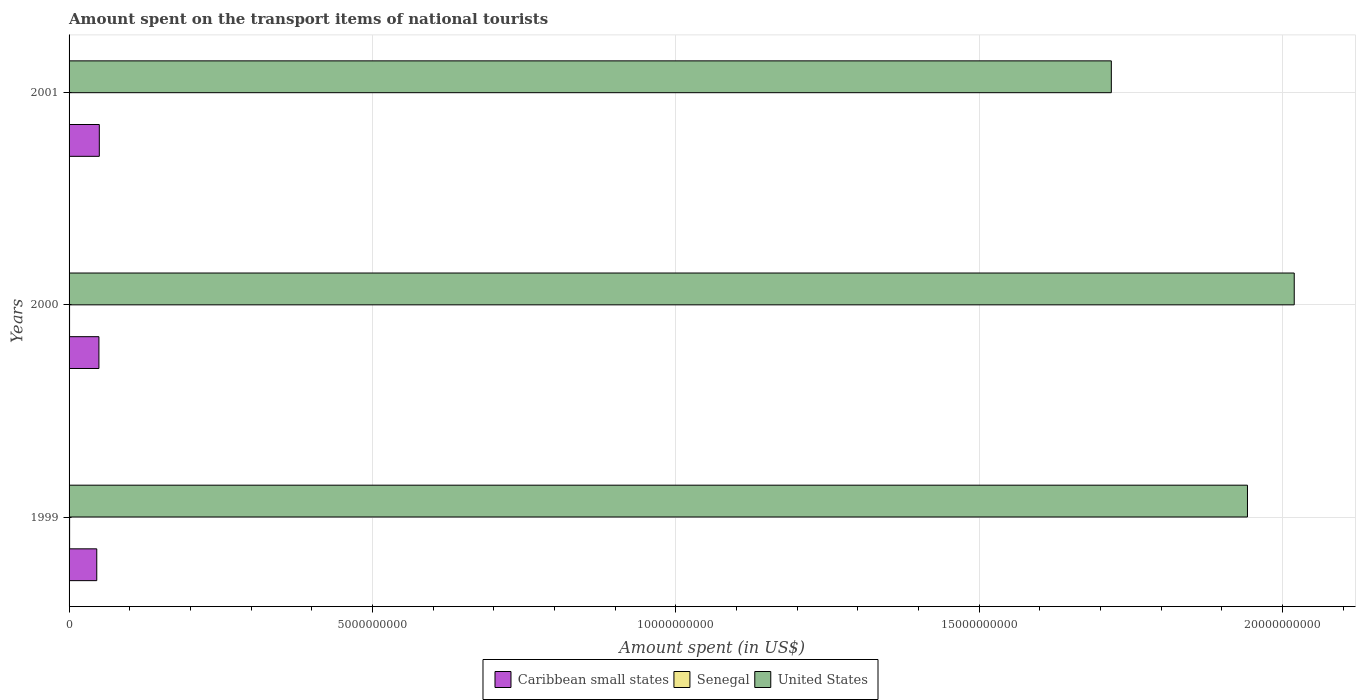How many different coloured bars are there?
Provide a short and direct response. 3. How many groups of bars are there?
Your answer should be very brief. 3. Are the number of bars on each tick of the Y-axis equal?
Ensure brevity in your answer.  Yes. How many bars are there on the 2nd tick from the top?
Your answer should be compact. 3. What is the label of the 3rd group of bars from the top?
Your answer should be compact. 1999. In how many cases, is the number of bars for a given year not equal to the number of legend labels?
Make the answer very short. 0. What is the amount spent on the transport items of national tourists in Caribbean small states in 2001?
Keep it short and to the point. 4.98e+08. Across all years, what is the maximum amount spent on the transport items of national tourists in United States?
Make the answer very short. 2.02e+1. Across all years, what is the minimum amount spent on the transport items of national tourists in United States?
Ensure brevity in your answer.  1.72e+1. In which year was the amount spent on the transport items of national tourists in Senegal maximum?
Your response must be concise. 1999. What is the total amount spent on the transport items of national tourists in United States in the graph?
Ensure brevity in your answer.  5.68e+1. What is the difference between the amount spent on the transport items of national tourists in United States in 2000 and that in 2001?
Offer a very short reply. 3.02e+09. What is the difference between the amount spent on the transport items of national tourists in Caribbean small states in 2000 and the amount spent on the transport items of national tourists in United States in 2001?
Provide a short and direct response. -1.67e+1. What is the average amount spent on the transport items of national tourists in Caribbean small states per year?
Ensure brevity in your answer.  4.82e+08. In the year 2001, what is the difference between the amount spent on the transport items of national tourists in United States and amount spent on the transport items of national tourists in Caribbean small states?
Keep it short and to the point. 1.67e+1. What is the ratio of the amount spent on the transport items of national tourists in United States in 1999 to that in 2000?
Keep it short and to the point. 0.96. Is the amount spent on the transport items of national tourists in Caribbean small states in 2000 less than that in 2001?
Give a very brief answer. Yes. Is the difference between the amount spent on the transport items of national tourists in United States in 2000 and 2001 greater than the difference between the amount spent on the transport items of national tourists in Caribbean small states in 2000 and 2001?
Ensure brevity in your answer.  Yes. What is the difference between the highest and the lowest amount spent on the transport items of national tourists in Senegal?
Offer a terse response. 8.00e+06. Is the sum of the amount spent on the transport items of national tourists in Senegal in 1999 and 2001 greater than the maximum amount spent on the transport items of national tourists in Caribbean small states across all years?
Ensure brevity in your answer.  No. What does the 3rd bar from the top in 2001 represents?
Your response must be concise. Caribbean small states. What does the 2nd bar from the bottom in 2000 represents?
Offer a very short reply. Senegal. How many bars are there?
Your response must be concise. 9. Does the graph contain grids?
Your answer should be very brief. Yes. How many legend labels are there?
Ensure brevity in your answer.  3. What is the title of the graph?
Ensure brevity in your answer.  Amount spent on the transport items of national tourists. What is the label or title of the X-axis?
Offer a terse response. Amount spent (in US$). What is the label or title of the Y-axis?
Your response must be concise. Years. What is the Amount spent (in US$) of Caribbean small states in 1999?
Provide a succinct answer. 4.57e+08. What is the Amount spent (in US$) of Senegal in 1999?
Keep it short and to the point. 9.00e+06. What is the Amount spent (in US$) in United States in 1999?
Offer a terse response. 1.94e+1. What is the Amount spent (in US$) of Caribbean small states in 2000?
Give a very brief answer. 4.92e+08. What is the Amount spent (in US$) of Senegal in 2000?
Keep it short and to the point. 8.00e+06. What is the Amount spent (in US$) in United States in 2000?
Your response must be concise. 2.02e+1. What is the Amount spent (in US$) of Caribbean small states in 2001?
Ensure brevity in your answer.  4.98e+08. What is the Amount spent (in US$) in United States in 2001?
Your answer should be very brief. 1.72e+1. Across all years, what is the maximum Amount spent (in US$) of Caribbean small states?
Your answer should be compact. 4.98e+08. Across all years, what is the maximum Amount spent (in US$) of Senegal?
Keep it short and to the point. 9.00e+06. Across all years, what is the maximum Amount spent (in US$) of United States?
Keep it short and to the point. 2.02e+1. Across all years, what is the minimum Amount spent (in US$) of Caribbean small states?
Your response must be concise. 4.57e+08. Across all years, what is the minimum Amount spent (in US$) of United States?
Keep it short and to the point. 1.72e+1. What is the total Amount spent (in US$) of Caribbean small states in the graph?
Provide a succinct answer. 1.45e+09. What is the total Amount spent (in US$) in Senegal in the graph?
Give a very brief answer. 1.80e+07. What is the total Amount spent (in US$) in United States in the graph?
Your answer should be very brief. 5.68e+1. What is the difference between the Amount spent (in US$) in Caribbean small states in 1999 and that in 2000?
Your response must be concise. -3.54e+07. What is the difference between the Amount spent (in US$) in United States in 1999 and that in 2000?
Give a very brief answer. -7.71e+08. What is the difference between the Amount spent (in US$) of Caribbean small states in 1999 and that in 2001?
Your response must be concise. -4.19e+07. What is the difference between the Amount spent (in US$) in Senegal in 1999 and that in 2001?
Keep it short and to the point. 8.00e+06. What is the difference between the Amount spent (in US$) in United States in 1999 and that in 2001?
Make the answer very short. 2.24e+09. What is the difference between the Amount spent (in US$) in Caribbean small states in 2000 and that in 2001?
Provide a succinct answer. -6.45e+06. What is the difference between the Amount spent (in US$) in United States in 2000 and that in 2001?
Your answer should be very brief. 3.02e+09. What is the difference between the Amount spent (in US$) in Caribbean small states in 1999 and the Amount spent (in US$) in Senegal in 2000?
Provide a succinct answer. 4.49e+08. What is the difference between the Amount spent (in US$) in Caribbean small states in 1999 and the Amount spent (in US$) in United States in 2000?
Keep it short and to the point. -1.97e+1. What is the difference between the Amount spent (in US$) in Senegal in 1999 and the Amount spent (in US$) in United States in 2000?
Offer a very short reply. -2.02e+1. What is the difference between the Amount spent (in US$) of Caribbean small states in 1999 and the Amount spent (in US$) of Senegal in 2001?
Offer a very short reply. 4.56e+08. What is the difference between the Amount spent (in US$) in Caribbean small states in 1999 and the Amount spent (in US$) in United States in 2001?
Provide a succinct answer. -1.67e+1. What is the difference between the Amount spent (in US$) of Senegal in 1999 and the Amount spent (in US$) of United States in 2001?
Keep it short and to the point. -1.72e+1. What is the difference between the Amount spent (in US$) in Caribbean small states in 2000 and the Amount spent (in US$) in Senegal in 2001?
Give a very brief answer. 4.91e+08. What is the difference between the Amount spent (in US$) in Caribbean small states in 2000 and the Amount spent (in US$) in United States in 2001?
Provide a short and direct response. -1.67e+1. What is the difference between the Amount spent (in US$) in Senegal in 2000 and the Amount spent (in US$) in United States in 2001?
Ensure brevity in your answer.  -1.72e+1. What is the average Amount spent (in US$) in Caribbean small states per year?
Offer a very short reply. 4.82e+08. What is the average Amount spent (in US$) in United States per year?
Give a very brief answer. 1.89e+1. In the year 1999, what is the difference between the Amount spent (in US$) of Caribbean small states and Amount spent (in US$) of Senegal?
Your response must be concise. 4.48e+08. In the year 1999, what is the difference between the Amount spent (in US$) of Caribbean small states and Amount spent (in US$) of United States?
Your response must be concise. -1.90e+1. In the year 1999, what is the difference between the Amount spent (in US$) of Senegal and Amount spent (in US$) of United States?
Make the answer very short. -1.94e+1. In the year 2000, what is the difference between the Amount spent (in US$) of Caribbean small states and Amount spent (in US$) of Senegal?
Provide a short and direct response. 4.84e+08. In the year 2000, what is the difference between the Amount spent (in US$) in Caribbean small states and Amount spent (in US$) in United States?
Ensure brevity in your answer.  -1.97e+1. In the year 2000, what is the difference between the Amount spent (in US$) of Senegal and Amount spent (in US$) of United States?
Keep it short and to the point. -2.02e+1. In the year 2001, what is the difference between the Amount spent (in US$) of Caribbean small states and Amount spent (in US$) of Senegal?
Provide a succinct answer. 4.97e+08. In the year 2001, what is the difference between the Amount spent (in US$) of Caribbean small states and Amount spent (in US$) of United States?
Provide a short and direct response. -1.67e+1. In the year 2001, what is the difference between the Amount spent (in US$) in Senegal and Amount spent (in US$) in United States?
Offer a very short reply. -1.72e+1. What is the ratio of the Amount spent (in US$) in Caribbean small states in 1999 to that in 2000?
Make the answer very short. 0.93. What is the ratio of the Amount spent (in US$) in Senegal in 1999 to that in 2000?
Offer a very short reply. 1.12. What is the ratio of the Amount spent (in US$) in United States in 1999 to that in 2000?
Provide a succinct answer. 0.96. What is the ratio of the Amount spent (in US$) of Caribbean small states in 1999 to that in 2001?
Provide a short and direct response. 0.92. What is the ratio of the Amount spent (in US$) in Senegal in 1999 to that in 2001?
Your answer should be very brief. 9. What is the ratio of the Amount spent (in US$) in United States in 1999 to that in 2001?
Make the answer very short. 1.13. What is the ratio of the Amount spent (in US$) in Caribbean small states in 2000 to that in 2001?
Your answer should be very brief. 0.99. What is the ratio of the Amount spent (in US$) of United States in 2000 to that in 2001?
Keep it short and to the point. 1.18. What is the difference between the highest and the second highest Amount spent (in US$) of Caribbean small states?
Your response must be concise. 6.45e+06. What is the difference between the highest and the second highest Amount spent (in US$) of United States?
Your answer should be compact. 7.71e+08. What is the difference between the highest and the lowest Amount spent (in US$) in Caribbean small states?
Your answer should be compact. 4.19e+07. What is the difference between the highest and the lowest Amount spent (in US$) in United States?
Make the answer very short. 3.02e+09. 